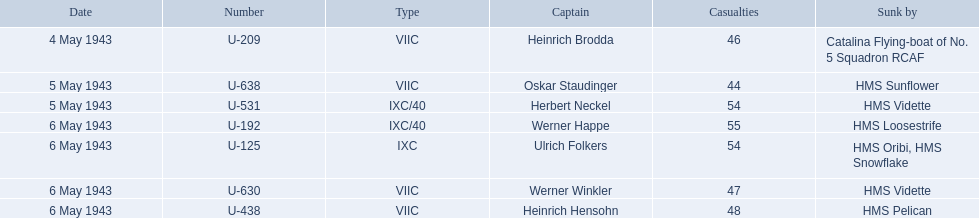Who commanded the u-boats? Heinrich Brodda, Oskar Staudinger, Herbert Neckel, Werner Happe, Ulrich Folkers, Werner Winkler, Heinrich Hensohn. When did the u-boat captains become lost? 4 May 1943, 5 May 1943, 5 May 1943, 6 May 1943, 6 May 1943, 6 May 1943, 6 May 1943. Out of these, who went missing on may 5th? Oskar Staudinger, Herbert Neckel. Apart from oskar staudinger, who else disappeared on that day? Herbert Neckel. 